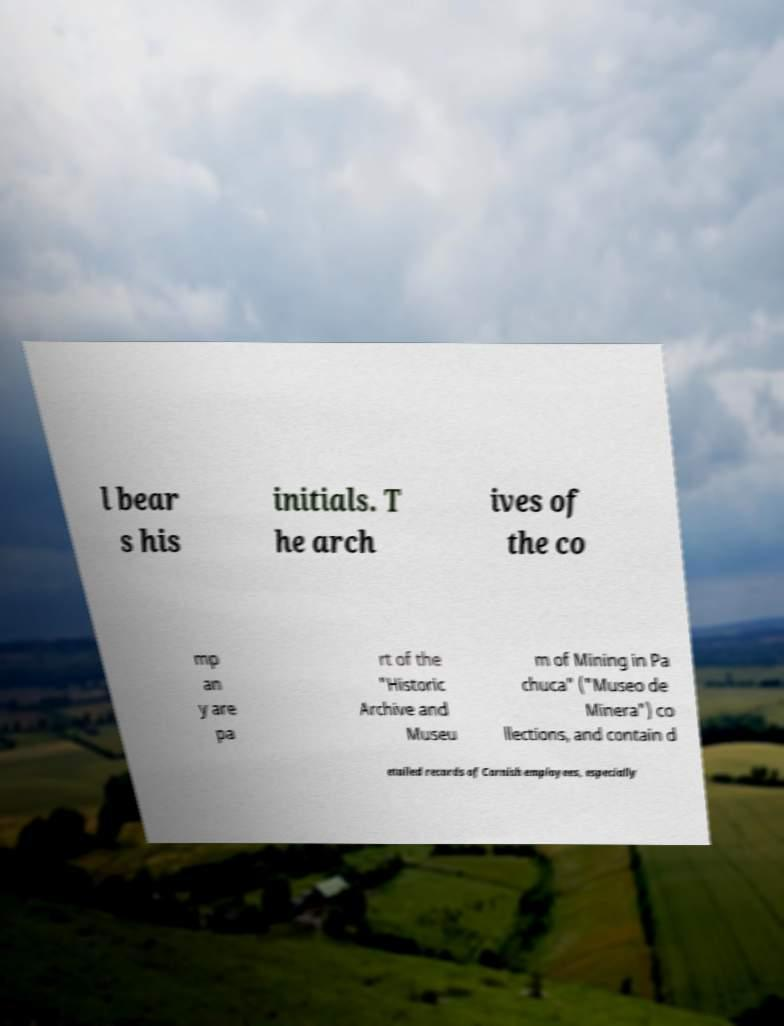Please identify and transcribe the text found in this image. l bear s his initials. T he arch ives of the co mp an y are pa rt of the "Historic Archive and Museu m of Mining in Pa chuca" ("Museo de Minera") co llections, and contain d etailed records of Cornish employees, especially 